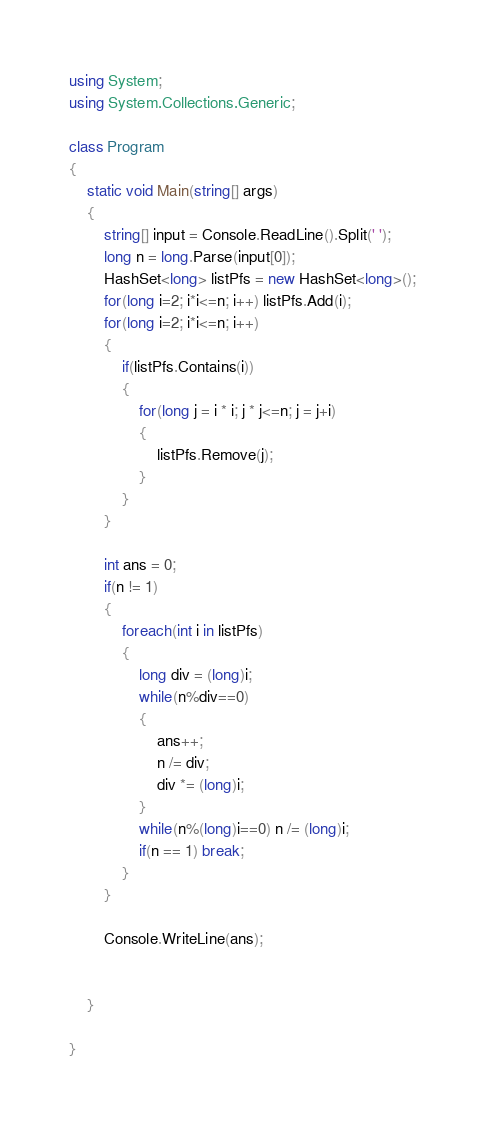Convert code to text. <code><loc_0><loc_0><loc_500><loc_500><_C#_>using System;
using System.Collections.Generic;

class Program
{
	static void Main(string[] args)
	{
		string[] input = Console.ReadLine().Split(' ');
		long n = long.Parse(input[0]);
		HashSet<long> listPfs = new HashSet<long>();
		for(long i=2; i*i<=n; i++) listPfs.Add(i);
		for(long i=2; i*i<=n; i++)
		{
			if(listPfs.Contains(i))
			{
				for(long j = i * i; j * j<=n; j = j+i)
				{
					listPfs.Remove(j);
				}
			}
		}

		int ans = 0;
		if(n != 1)
		{
			foreach(int i in listPfs)
			{
				long div = (long)i;
				while(n%div==0)
				{
					ans++;
					n /= div;
					div *= (long)i;
				}
				while(n%(long)i==0) n /= (long)i;
				if(n == 1) break;
			}
		}

		Console.WriteLine(ans);


	}

}
</code> 